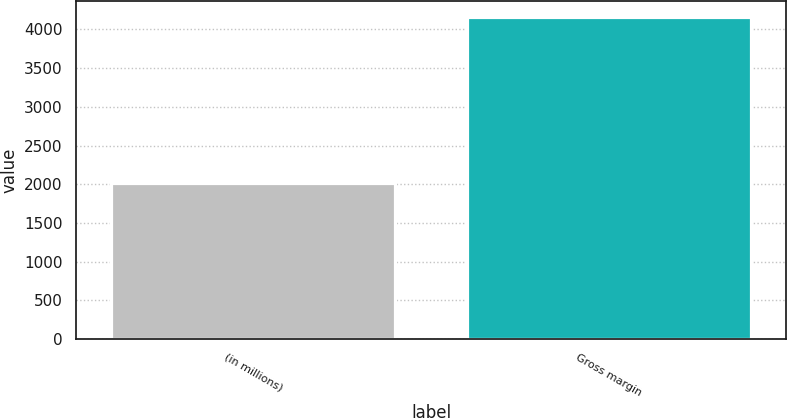<chart> <loc_0><loc_0><loc_500><loc_500><bar_chart><fcel>(in millions)<fcel>Gross margin<nl><fcel>2011<fcel>4162<nl></chart> 